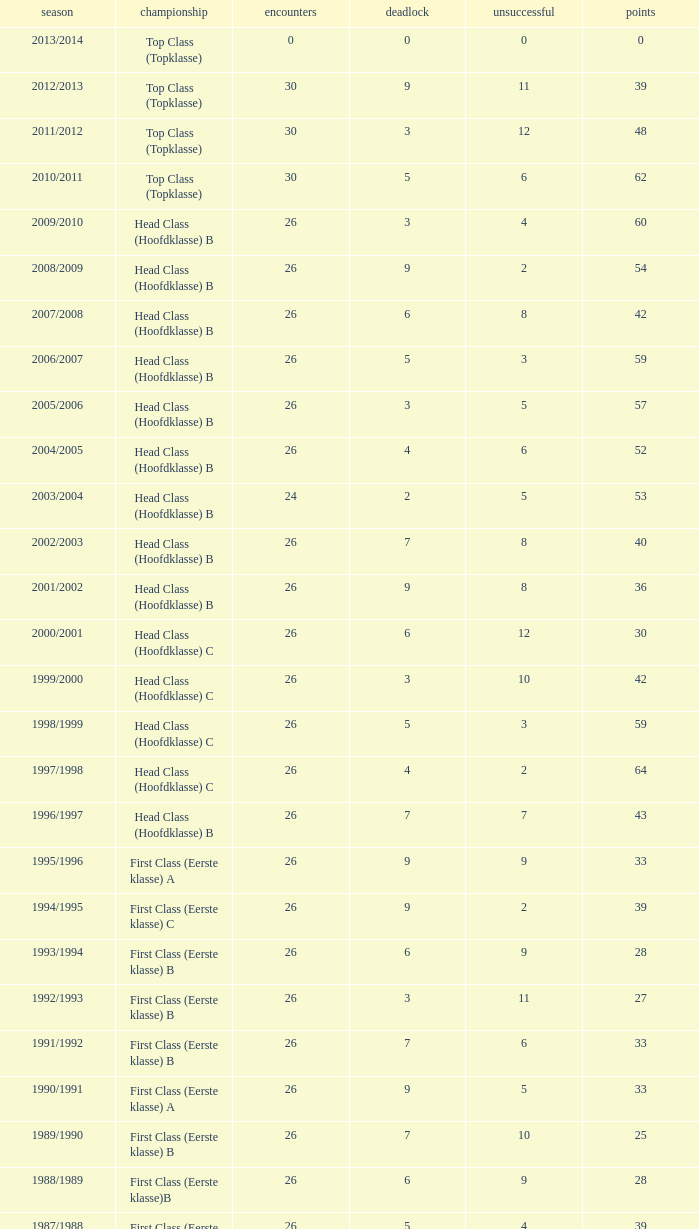What is the total number of matches with a loss less than 5 in the 2008/2009 season and has a draw larger than 9? 0.0. 